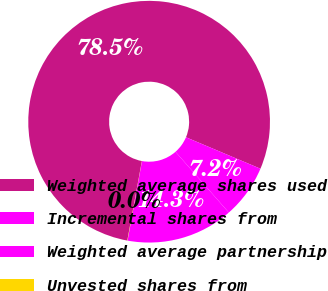<chart> <loc_0><loc_0><loc_500><loc_500><pie_chart><fcel>Weighted average shares used<fcel>Incremental shares from<fcel>Weighted average partnership<fcel>Unvested shares from<nl><fcel>78.47%<fcel>7.18%<fcel>14.32%<fcel>0.03%<nl></chart> 